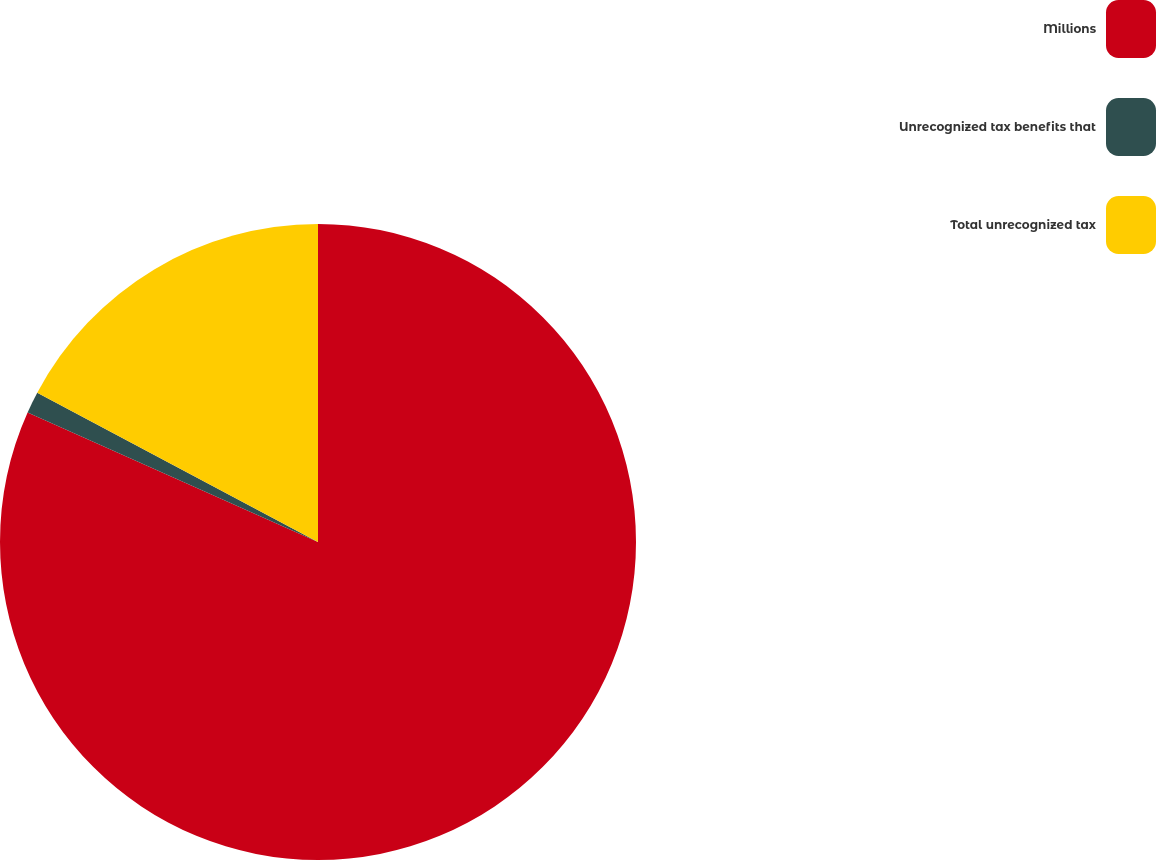<chart> <loc_0><loc_0><loc_500><loc_500><pie_chart><fcel>Millions<fcel>Unrecognized tax benefits that<fcel>Total unrecognized tax<nl><fcel>81.69%<fcel>1.1%<fcel>17.22%<nl></chart> 